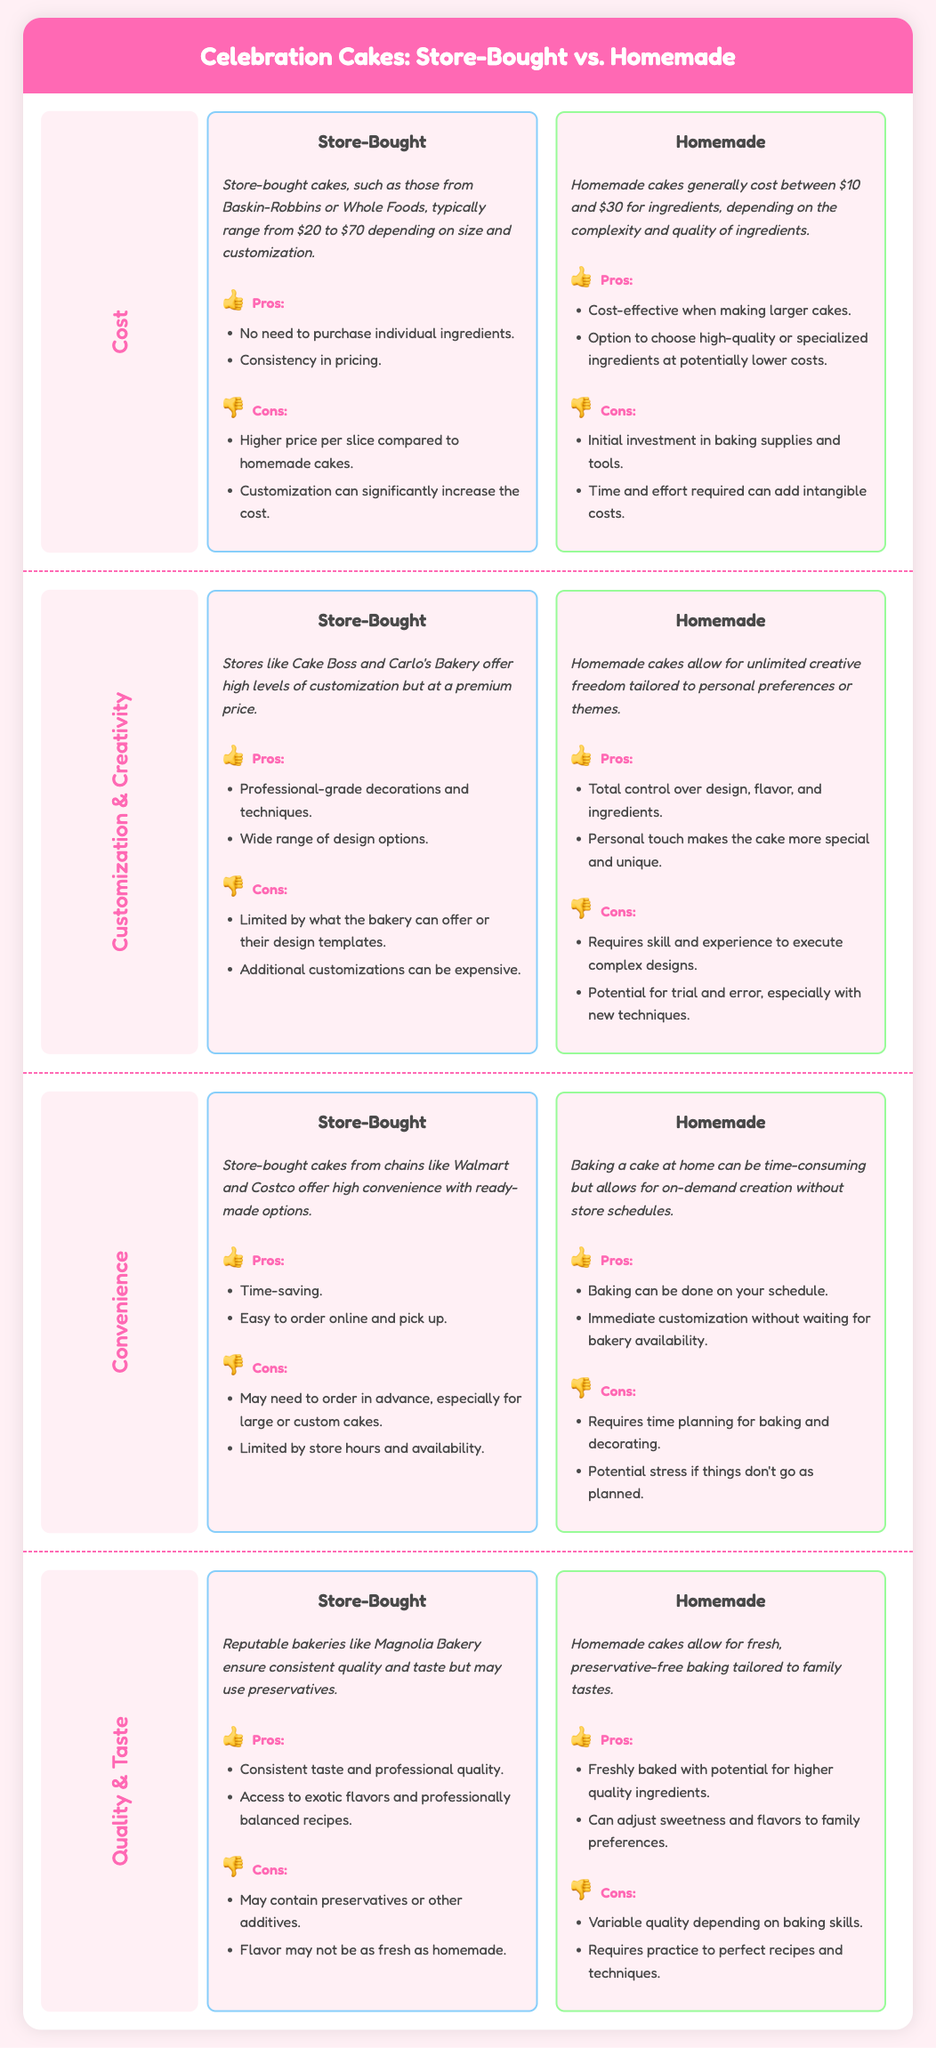What is the cost range of store-bought cakes? The cost range for store-bought cakes typically ranges from $20 to $70 depending on size and customization.
Answer: $20 to $70 What are two pros of homemade cakes? The document lists that pros of homemade cakes include being cost-effective when making larger cakes and the option to choose high-quality or specialized ingredients at potentially lower costs.
Answer: Cost-effective and high-quality ingredients What is the main advantage of store-bought cakes regarding convenience? The document states that the main advantage of store-bought cakes is time-saving.
Answer: Time-saving What are the cons of homemade cakes in terms of customization? The cons include requiring skill and experience to execute complex designs and the potential for trial and error especially with new techniques.
Answer: Requires skill and trial and error What is the price range for homemade cakes? The price range for homemade cakes generally costs between $10 and $30 for ingredients depending on the complexity and quality of ingredients.
Answer: $10 to $30 Which type of cake offers total control over design, flavor, and ingredients? The document indicates that homemade cakes allow for total control over design, flavor, and ingredients.
Answer: Homemade What is one con of store-bought cakes related to quality? One con listed in the document is that store-bought cakes may contain preservatives or other additives.
Answer: May contain preservatives How does the taste of homemade cakes compare to store-bought cakes? Homemade cakes are described as having freshly baked quality, which may not be the same as the taste of store-bought cakes that could use preservatives.
Answer: Freshly baked vs. preservatives What is the main unique selling point of store-bought cakes regarding customization? Store-bought cakes offer professional-grade decorations and techniques as a unique selling point concerning customization.
Answer: Professional-grade decorations 